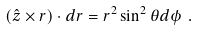<formula> <loc_0><loc_0><loc_500><loc_500>( \hat { z } \times r ) \cdot d r = r ^ { 2 } \sin ^ { 2 } \theta d \phi \ .</formula> 